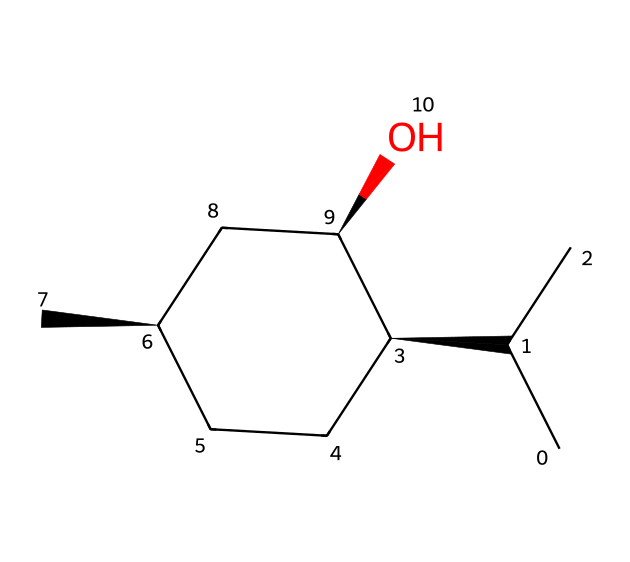What is the molecular formula for menthol? To determine the molecular formula from the SMILES representation, we identify the number of carbon (C), hydrogen (H), and oxygen (O) atoms present. The structure reveals 10 carbon atoms, 20 hydrogen atoms, and 1 oxygen atom. Therefore, the molecular formula is C10H20O.
Answer: C10H20O How many chiral centers are present in menthol? A chiral center is typically identified by looking for carbon atoms bonded to four different substituents. In the given structure, there are three carbon atoms that meet this criterion, indicating there are three chiral centers.
Answer: 3 What type of chemical is menthol? Menthol is classified as a monoterpene alcohol due to its derivation from terpenes and the presence of an alcohol (-OH) functional group in the structure.
Answer: monoterpene alcohol What property of menthol is responsible for its cooling sensation? The presence of the hydroxyl (-OH) group in menthol's structure contributes to its activation of the TRPM8 receptor, which is known to mediate cool sensations. Therefore, the cooling sensation is attributed to the hydroxyl group.
Answer: hydroxyl group What type of functional group is featured in menthol? The essential functional group present in menthol is the alcohol group (-OH), which is crucial for its properties, including its solubility in polar solvents.
Answer: alcohol group How many rings are present in menthol's structure? By examining the SMILES representation, it can be observed that there is one cyclohexane ring structure indicated by the notation, signifying the presence of a single ring within the molecule.
Answer: 1 